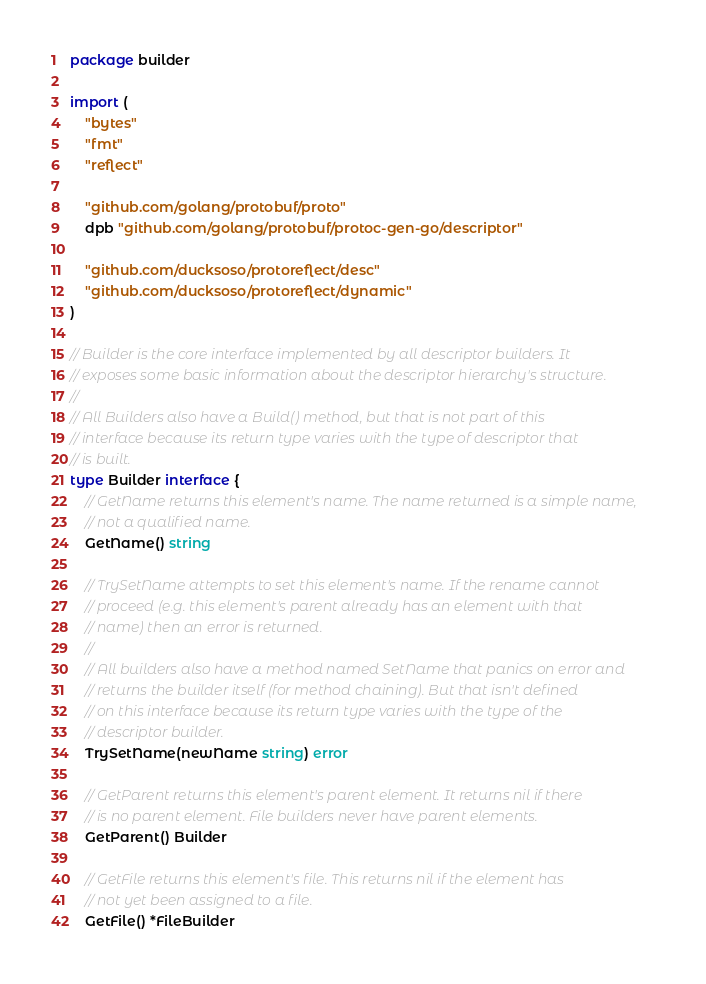<code> <loc_0><loc_0><loc_500><loc_500><_Go_>package builder

import (
	"bytes"
	"fmt"
	"reflect"

	"github.com/golang/protobuf/proto"
	dpb "github.com/golang/protobuf/protoc-gen-go/descriptor"

	"github.com/ducksoso/protoreflect/desc"
	"github.com/ducksoso/protoreflect/dynamic"
)

// Builder is the core interface implemented by all descriptor builders. It
// exposes some basic information about the descriptor hierarchy's structure.
//
// All Builders also have a Build() method, but that is not part of this
// interface because its return type varies with the type of descriptor that
// is built.
type Builder interface {
	// GetName returns this element's name. The name returned is a simple name,
	// not a qualified name.
	GetName() string

	// TrySetName attempts to set this element's name. If the rename cannot
	// proceed (e.g. this element's parent already has an element with that
	// name) then an error is returned.
	//
	// All builders also have a method named SetName that panics on error and
	// returns the builder itself (for method chaining). But that isn't defined
	// on this interface because its return type varies with the type of the
	// descriptor builder.
	TrySetName(newName string) error

	// GetParent returns this element's parent element. It returns nil if there
	// is no parent element. File builders never have parent elements.
	GetParent() Builder

	// GetFile returns this element's file. This returns nil if the element has
	// not yet been assigned to a file.
	GetFile() *FileBuilder
</code> 